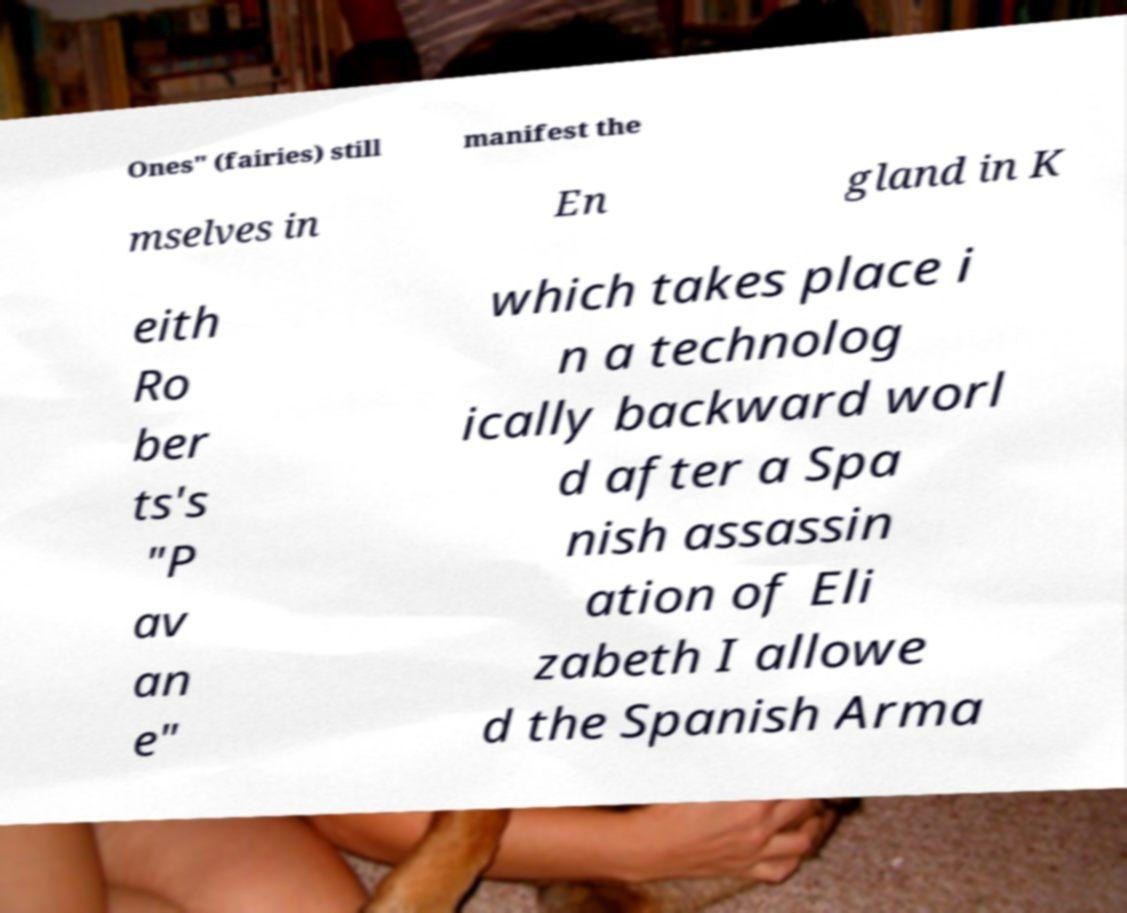Please read and relay the text visible in this image. What does it say? Ones" (fairies) still manifest the mselves in En gland in K eith Ro ber ts's "P av an e" which takes place i n a technolog ically backward worl d after a Spa nish assassin ation of Eli zabeth I allowe d the Spanish Arma 